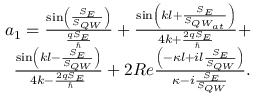<formula> <loc_0><loc_0><loc_500><loc_500>\begin{array} { r } { a _ { 1 } = \frac { \sin \left ( \frac { S _ { E } } { S _ { Q W } } \right ) } { \frac { q S _ { E } } { } } + \frac { \sin \left ( k l + \frac { S _ { E } } { S _ { { Q W } _ { a t } } } \right ) } { 4 k + \frac { 2 q S _ { E } } { } } + } \\ { \frac { \sin \left ( k l - \frac { S _ { E } } { S _ { Q W } } \right ) } { 4 k - \frac { 2 q S _ { E } } { } } + 2 R e \frac { \left ( - \kappa l + i l \frac { S _ { E } } { S _ { Q W } } \right ) } { \kappa - i \frac { S _ { E } } { S _ { Q W } } } . } \end{array}</formula> 